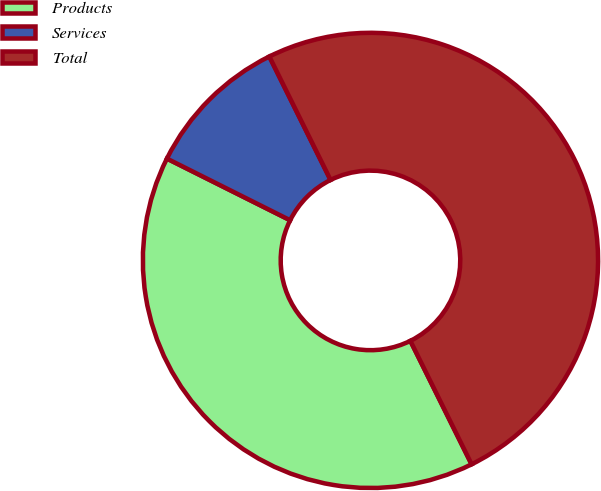<chart> <loc_0><loc_0><loc_500><loc_500><pie_chart><fcel>Products<fcel>Services<fcel>Total<nl><fcel>39.71%<fcel>10.29%<fcel>50.0%<nl></chart> 